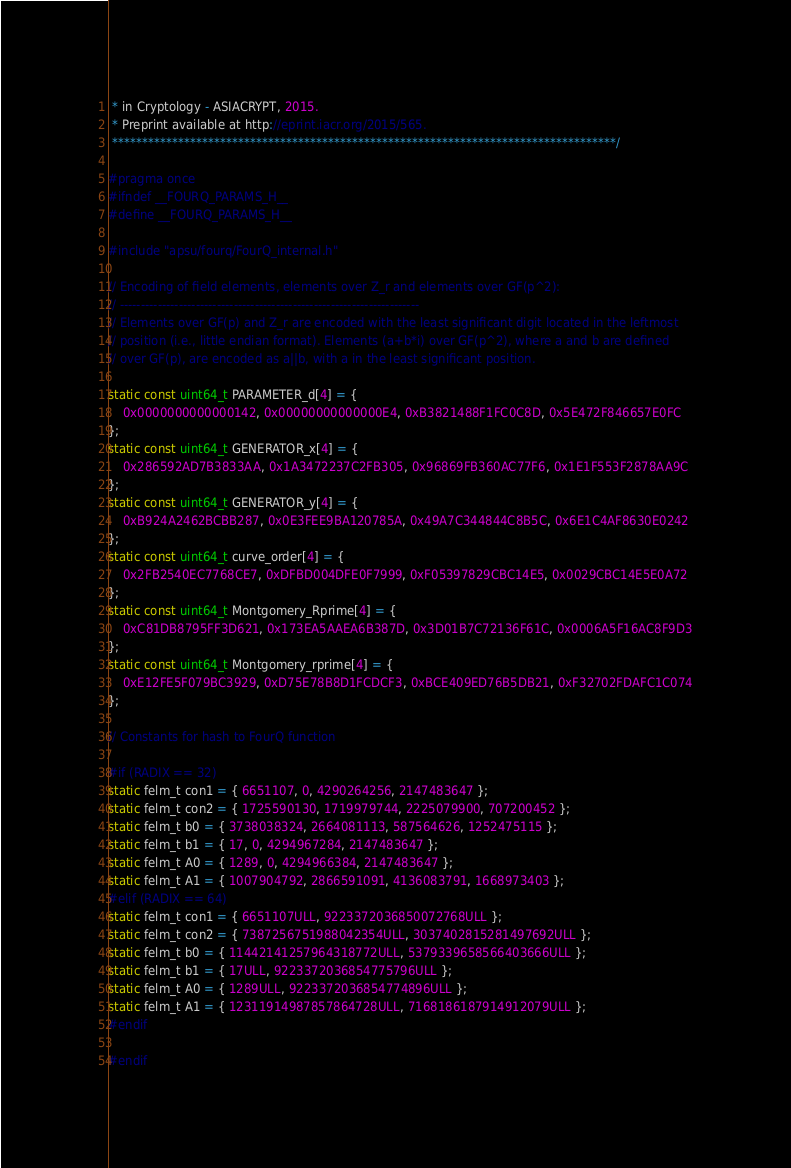<code> <loc_0><loc_0><loc_500><loc_500><_C_> * in Cryptology - ASIACRYPT, 2015.
 * Preprint available at http://eprint.iacr.org/2015/565.
 ************************************************************************************/

#pragma once
#ifndef __FOURQ_PARAMS_H__
#define __FOURQ_PARAMS_H__

#include "apsu/fourq/FourQ_internal.h"

// Encoding of field elements, elements over Z_r and elements over GF(p^2):
// -----------------------------------------------------------------------
// Elements over GF(p) and Z_r are encoded with the least significant digit located in the leftmost
// position (i.e., little endian format). Elements (a+b*i) over GF(p^2), where a and b are defined
// over GF(p), are encoded as a||b, with a in the least significant position.

static const uint64_t PARAMETER_d[4] = {
    0x0000000000000142, 0x00000000000000E4, 0xB3821488F1FC0C8D, 0x5E472F846657E0FC
};
static const uint64_t GENERATOR_x[4] = {
    0x286592AD7B3833AA, 0x1A3472237C2FB305, 0x96869FB360AC77F6, 0x1E1F553F2878AA9C
};
static const uint64_t GENERATOR_y[4] = {
    0xB924A2462BCBB287, 0x0E3FEE9BA120785A, 0x49A7C344844C8B5C, 0x6E1C4AF8630E0242
};
static const uint64_t curve_order[4] = {
    0x2FB2540EC7768CE7, 0xDFBD004DFE0F7999, 0xF05397829CBC14E5, 0x0029CBC14E5E0A72
};
static const uint64_t Montgomery_Rprime[4] = {
    0xC81DB8795FF3D621, 0x173EA5AAEA6B387D, 0x3D01B7C72136F61C, 0x0006A5F16AC8F9D3
};
static const uint64_t Montgomery_rprime[4] = {
    0xE12FE5F079BC3929, 0xD75E78B8D1FCDCF3, 0xBCE409ED76B5DB21, 0xF32702FDAFC1C074
};

// Constants for hash to FourQ function

#if (RADIX == 32)
static felm_t con1 = { 6651107, 0, 4290264256, 2147483647 };
static felm_t con2 = { 1725590130, 1719979744, 2225079900, 707200452 };
static felm_t b0 = { 3738038324, 2664081113, 587564626, 1252475115 };
static felm_t b1 = { 17, 0, 4294967284, 2147483647 };
static felm_t A0 = { 1289, 0, 4294966384, 2147483647 };
static felm_t A1 = { 1007904792, 2866591091, 4136083791, 1668973403 };
#elif (RADIX == 64)
static felm_t con1 = { 6651107ULL, 9223372036850072768ULL };
static felm_t con2 = { 7387256751988042354ULL, 3037402815281497692ULL };
static felm_t b0 = { 11442141257964318772ULL, 5379339658566403666ULL };
static felm_t b1 = { 17ULL, 9223372036854775796ULL };
static felm_t A0 = { 1289ULL, 9223372036854774896ULL };
static felm_t A1 = { 12311914987857864728ULL, 7168186187914912079ULL };
#endif

#endif
</code> 